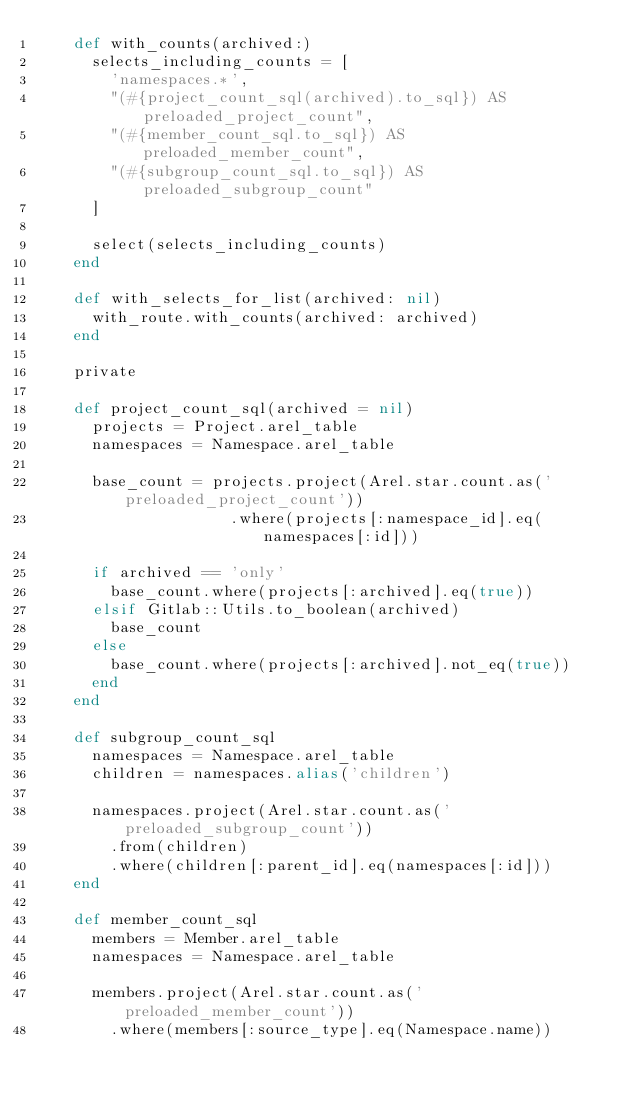<code> <loc_0><loc_0><loc_500><loc_500><_Ruby_>    def with_counts(archived:)
      selects_including_counts = [
        'namespaces.*',
        "(#{project_count_sql(archived).to_sql}) AS preloaded_project_count",
        "(#{member_count_sql.to_sql}) AS preloaded_member_count",
        "(#{subgroup_count_sql.to_sql}) AS preloaded_subgroup_count"
      ]

      select(selects_including_counts)
    end

    def with_selects_for_list(archived: nil)
      with_route.with_counts(archived: archived)
    end

    private

    def project_count_sql(archived = nil)
      projects = Project.arel_table
      namespaces = Namespace.arel_table

      base_count = projects.project(Arel.star.count.as('preloaded_project_count'))
                     .where(projects[:namespace_id].eq(namespaces[:id]))

      if archived == 'only'
        base_count.where(projects[:archived].eq(true))
      elsif Gitlab::Utils.to_boolean(archived)
        base_count
      else
        base_count.where(projects[:archived].not_eq(true))
      end
    end

    def subgroup_count_sql
      namespaces = Namespace.arel_table
      children = namespaces.alias('children')

      namespaces.project(Arel.star.count.as('preloaded_subgroup_count'))
        .from(children)
        .where(children[:parent_id].eq(namespaces[:id]))
    end

    def member_count_sql
      members = Member.arel_table
      namespaces = Namespace.arel_table

      members.project(Arel.star.count.as('preloaded_member_count'))
        .where(members[:source_type].eq(Namespace.name))</code> 